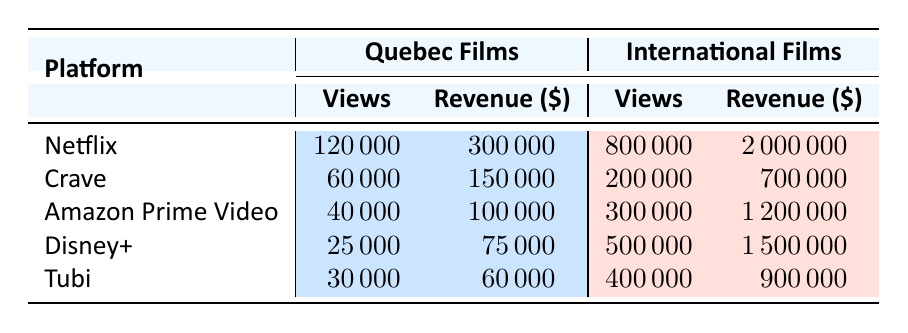What streaming platform had the highest number of views for Quebec films? From the table, Netflix has 120,000 views for Quebec films, which is higher than the views for Quebec films on Crave (60,000), Amazon Prime Video (40,000), Disney+ (25,000), and Tubi (30,000). Therefore, Netflix has the highest number of views.
Answer: Netflix What is the total revenue generated from international films on Tubi and Amazon Prime Video combined? The revenue from international films on Tubi is 900,000 and on Amazon Prime Video is 1,200,000. To find the total, we calculate 900,000 + 1,200,000 = 2,100,000.
Answer: 2,100,000 Did Disney+ generate more revenue from Quebec films than from international films? Disney+ generated 75,000 from Quebec films and 1,500,000 from international films. Since 75,000 is less than 1,500,000, the statement is false.
Answer: No What streaming platform has the lowest view count for Quebec films? From the table, Disney+ has the lowest views for Quebec films at 25,000, which is less than Crave (60,000), Amazon Prime Video (40,000), Netflix (120,000), and Tubi (30,000).
Answer: Disney+ What is the average number of views for Quebec films across all platforms? The views for Quebec films are 120,000 (Netflix), 60,000 (Crave), 40,000 (Amazon Prime Video), 25,000 (Disney+), and 30,000 (Tubi). Adding these gives 120,000 + 60,000 + 40,000 + 25,000 + 30,000 = 275,000. There are 5 platforms, so the average views are 275,000 / 5 = 55,000.
Answer: 55,000 Which platform has the largest revenue difference between international films and Quebec films? We find the difference in revenue for each platform. For Netflix, it's 2,000,000 - 300,000 = 1,700,000. For Crave: 700,000 - 150,000 = 550,000. For Amazon Prime Video: 1,200,000 - 100,000 = 1,100,000. For Disney+: 1,500,000 - 75,000 = 1,425,000. For Tubi: 900,000 - 60,000 = 840,000. The largest difference is for Netflix at 1,700,000.
Answer: Netflix Is the revenue from Quebec films higher on Crave than on Disney+? Crave’s revenue from Quebec films is 150,000, while Disney+’s revenue is 75,000. Since 150,000 is greater than 75,000, the statement is true.
Answer: Yes 